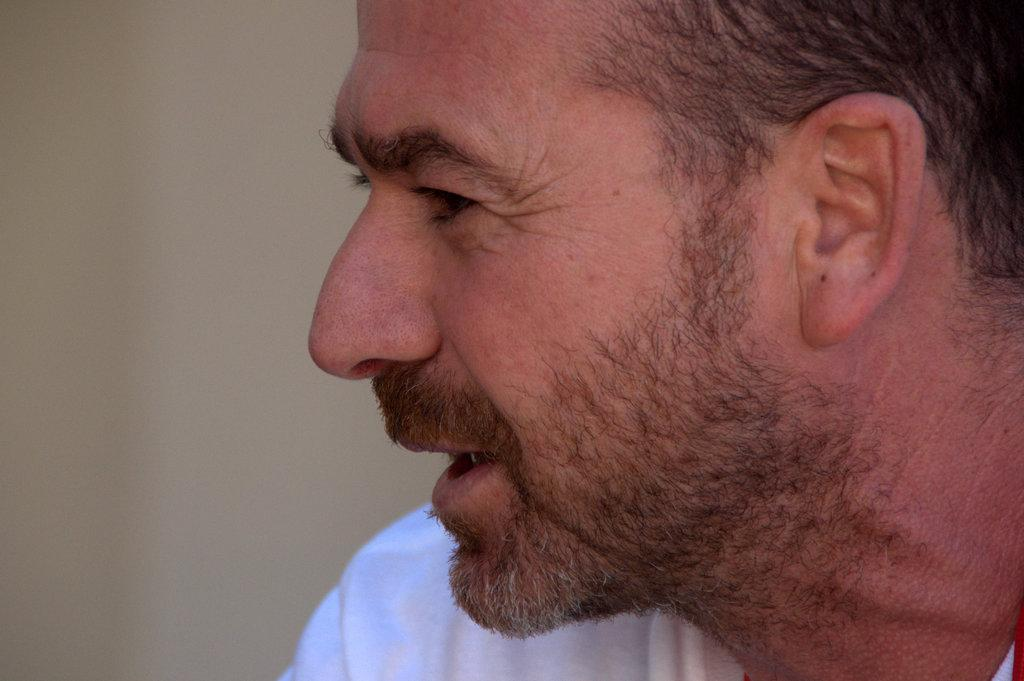What is the main subject of the image? There is a person's face in the image. How many hours does the box in the image have? There is no box present in the image, so it is not possible to determine how many hours it might have. 